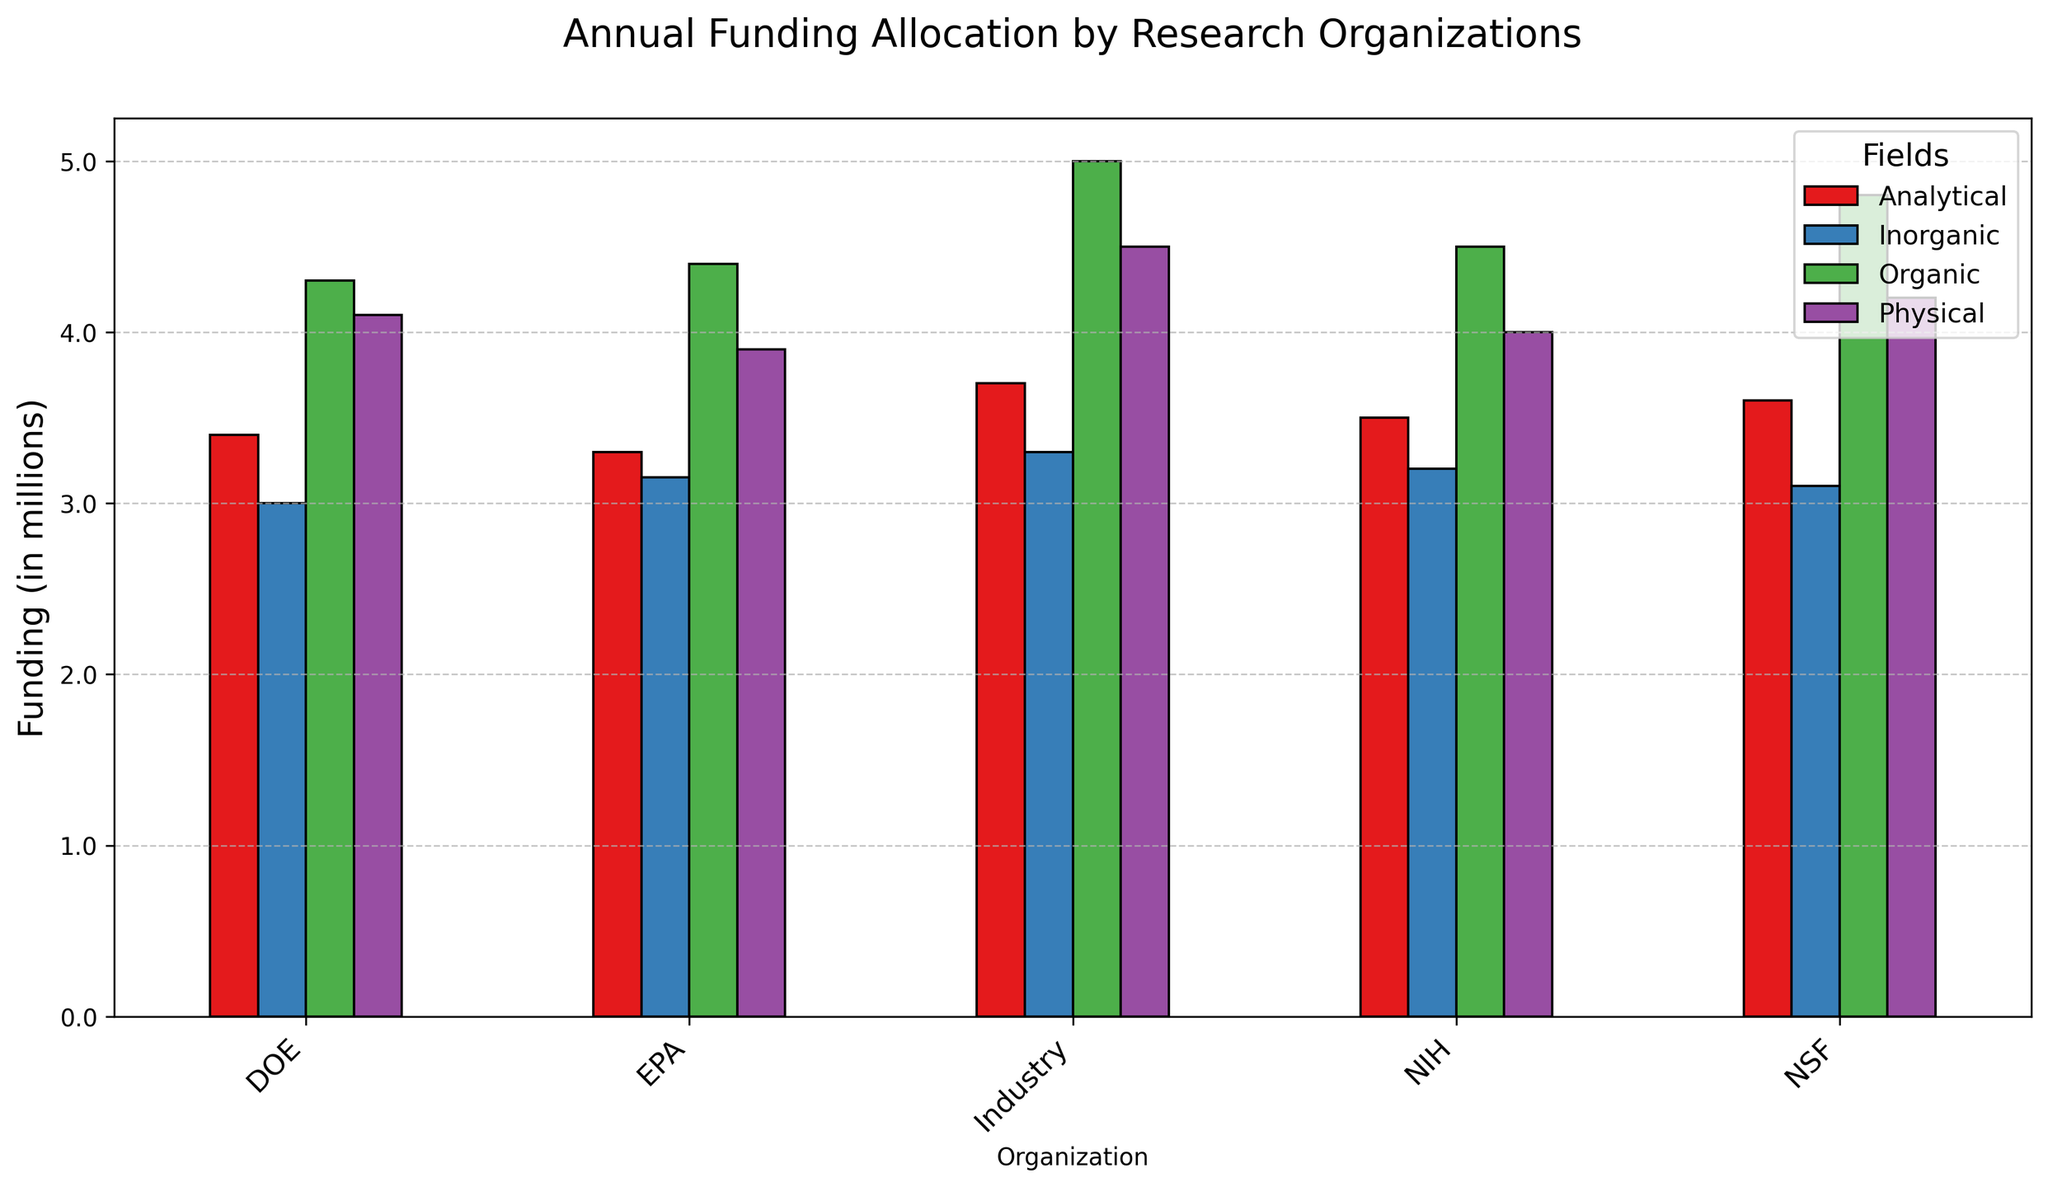Which organization allocated the highest funding for Organic chemistry? Observe the bar heights for Organic chemistry across all organizations. NIH has the highest bar for Organic chemistry.
Answer: NIH Which field received the least funding from the DOE? Compare the bar heights for all fields under DOE. Inorganic chemistry has the shortest bar.
Answer: Inorganic What is the total funding for Physical chemistry across all organizations? Sum up the funding values for Physical chemistry for each organization: NIH (4000000), NSF (4200000), DOE (4100000), EPA (3900000), Industry (4500000). Total funding is 4000000 + 4200000 + 4100000 + 3900000 + 4500000 = 20700000.
Answer: 20.7 million How does the funding allocated by EPA to Inorganic chemistry compare to that by NIH? Compare the bar heights of EPA and NIH for Inorganic chemistry. NIH has a taller bar than EPA.
Answer: NIH's funding is higher What is the average funding for the Analytical chemistry field across all organizations? Add the funding values for Analytical chemistry for each organization and divide by the number of organizations: (3500000 + 3600000 + 3400000 + 3300000 + 3700000) / 5. Sum is 17500000, average is 17500000 / 5 = 3500000.
Answer: 3.5 million What is the total funding allocated by the NSF across all fields? Sum the funding values for all fields under NSF: 4800000 + 3100000 + 4200000 + 3600000. Total funding is 4800000 + 3100000 + 4200000 + 3600000 = 15700000.
Answer: 15.7 million Which field has the most consistent funding allocation across all organizations? Observe the variation in bar heights for each field across all organizations. Physical chemistry bars appear to have the least variance.
Answer: Physical Which field had the highest variance in funding between the organizations? Compare the range of bar heights across all organizations for each field. Organic chemistry shows the greatest variance.
Answer: Organic 